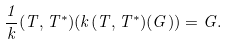Convert formula to latex. <formula><loc_0><loc_0><loc_500><loc_500>\frac { 1 } { k } ( T , T ^ { * } ) ( k ( T , T ^ { * } ) ( G ) ) = G .</formula> 